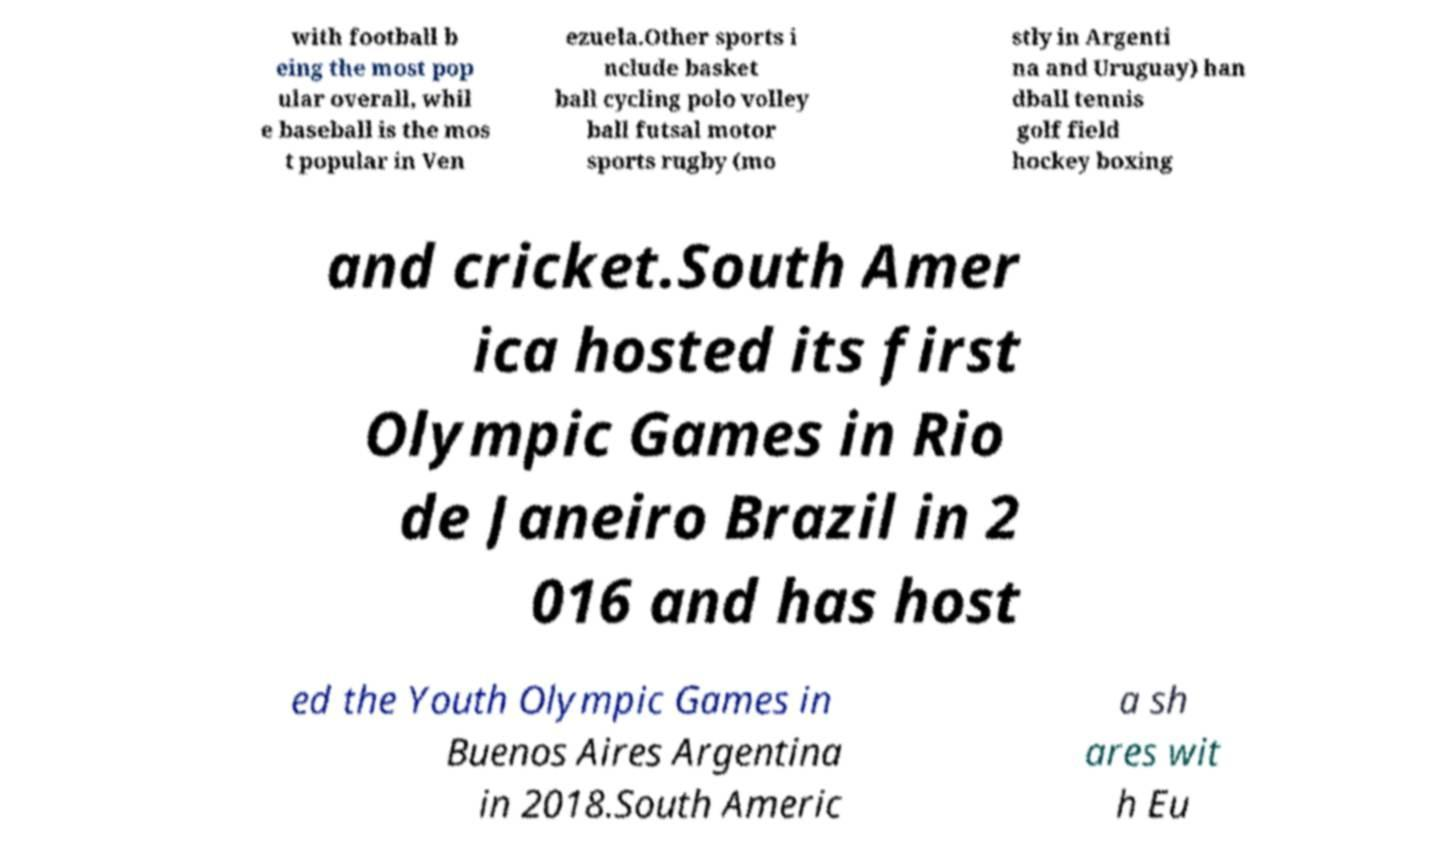Can you accurately transcribe the text from the provided image for me? with football b eing the most pop ular overall, whil e baseball is the mos t popular in Ven ezuela.Other sports i nclude basket ball cycling polo volley ball futsal motor sports rugby (mo stly in Argenti na and Uruguay) han dball tennis golf field hockey boxing and cricket.South Amer ica hosted its first Olympic Games in Rio de Janeiro Brazil in 2 016 and has host ed the Youth Olympic Games in Buenos Aires Argentina in 2018.South Americ a sh ares wit h Eu 